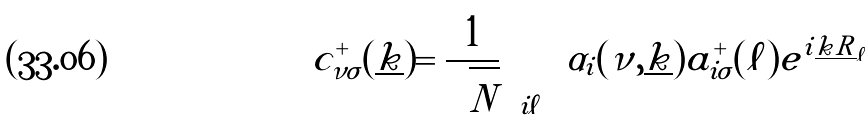<formula> <loc_0><loc_0><loc_500><loc_500>c ^ { + } _ { \nu \sigma } ( \underline { k } ) = \frac { 1 } { \sqrt { N } } \sum _ { i \ell } \alpha _ { i } ( \nu , \underline { k } ) a ^ { + } _ { i \sigma } ( \ell ) e ^ { i \underline { k } \underline { R } _ { \ell } }</formula> 